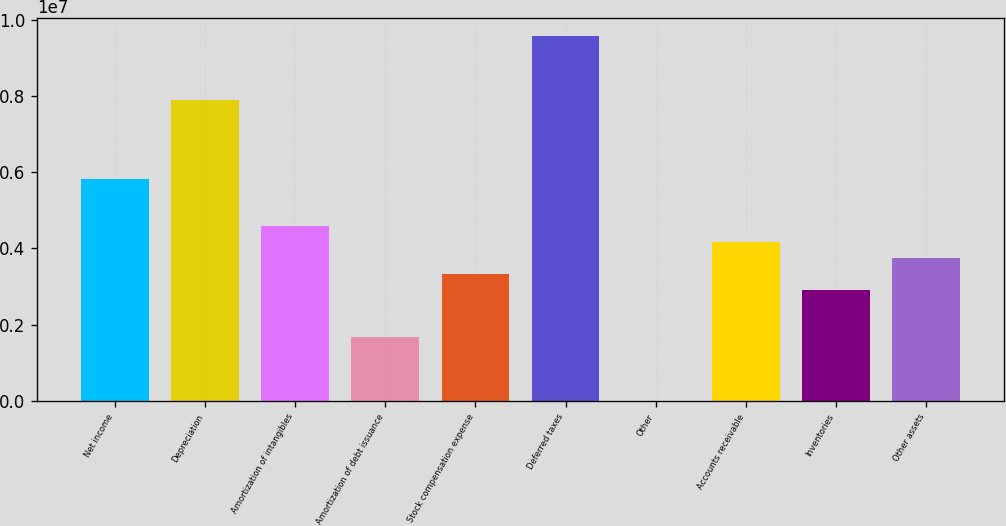<chart> <loc_0><loc_0><loc_500><loc_500><bar_chart><fcel>Net income<fcel>Depreciation<fcel>Amortization of intangibles<fcel>Amortization of debt issuance<fcel>Stock compensation expense<fcel>Deferred taxes<fcel>Other<fcel>Accounts receivable<fcel>Inventories<fcel>Other assets<nl><fcel>5.82593e+06<fcel>7.9061e+06<fcel>4.57783e+06<fcel>1.6656e+06<fcel>3.32973e+06<fcel>9.57023e+06<fcel>1468<fcel>4.1618e+06<fcel>2.9137e+06<fcel>3.74577e+06<nl></chart> 